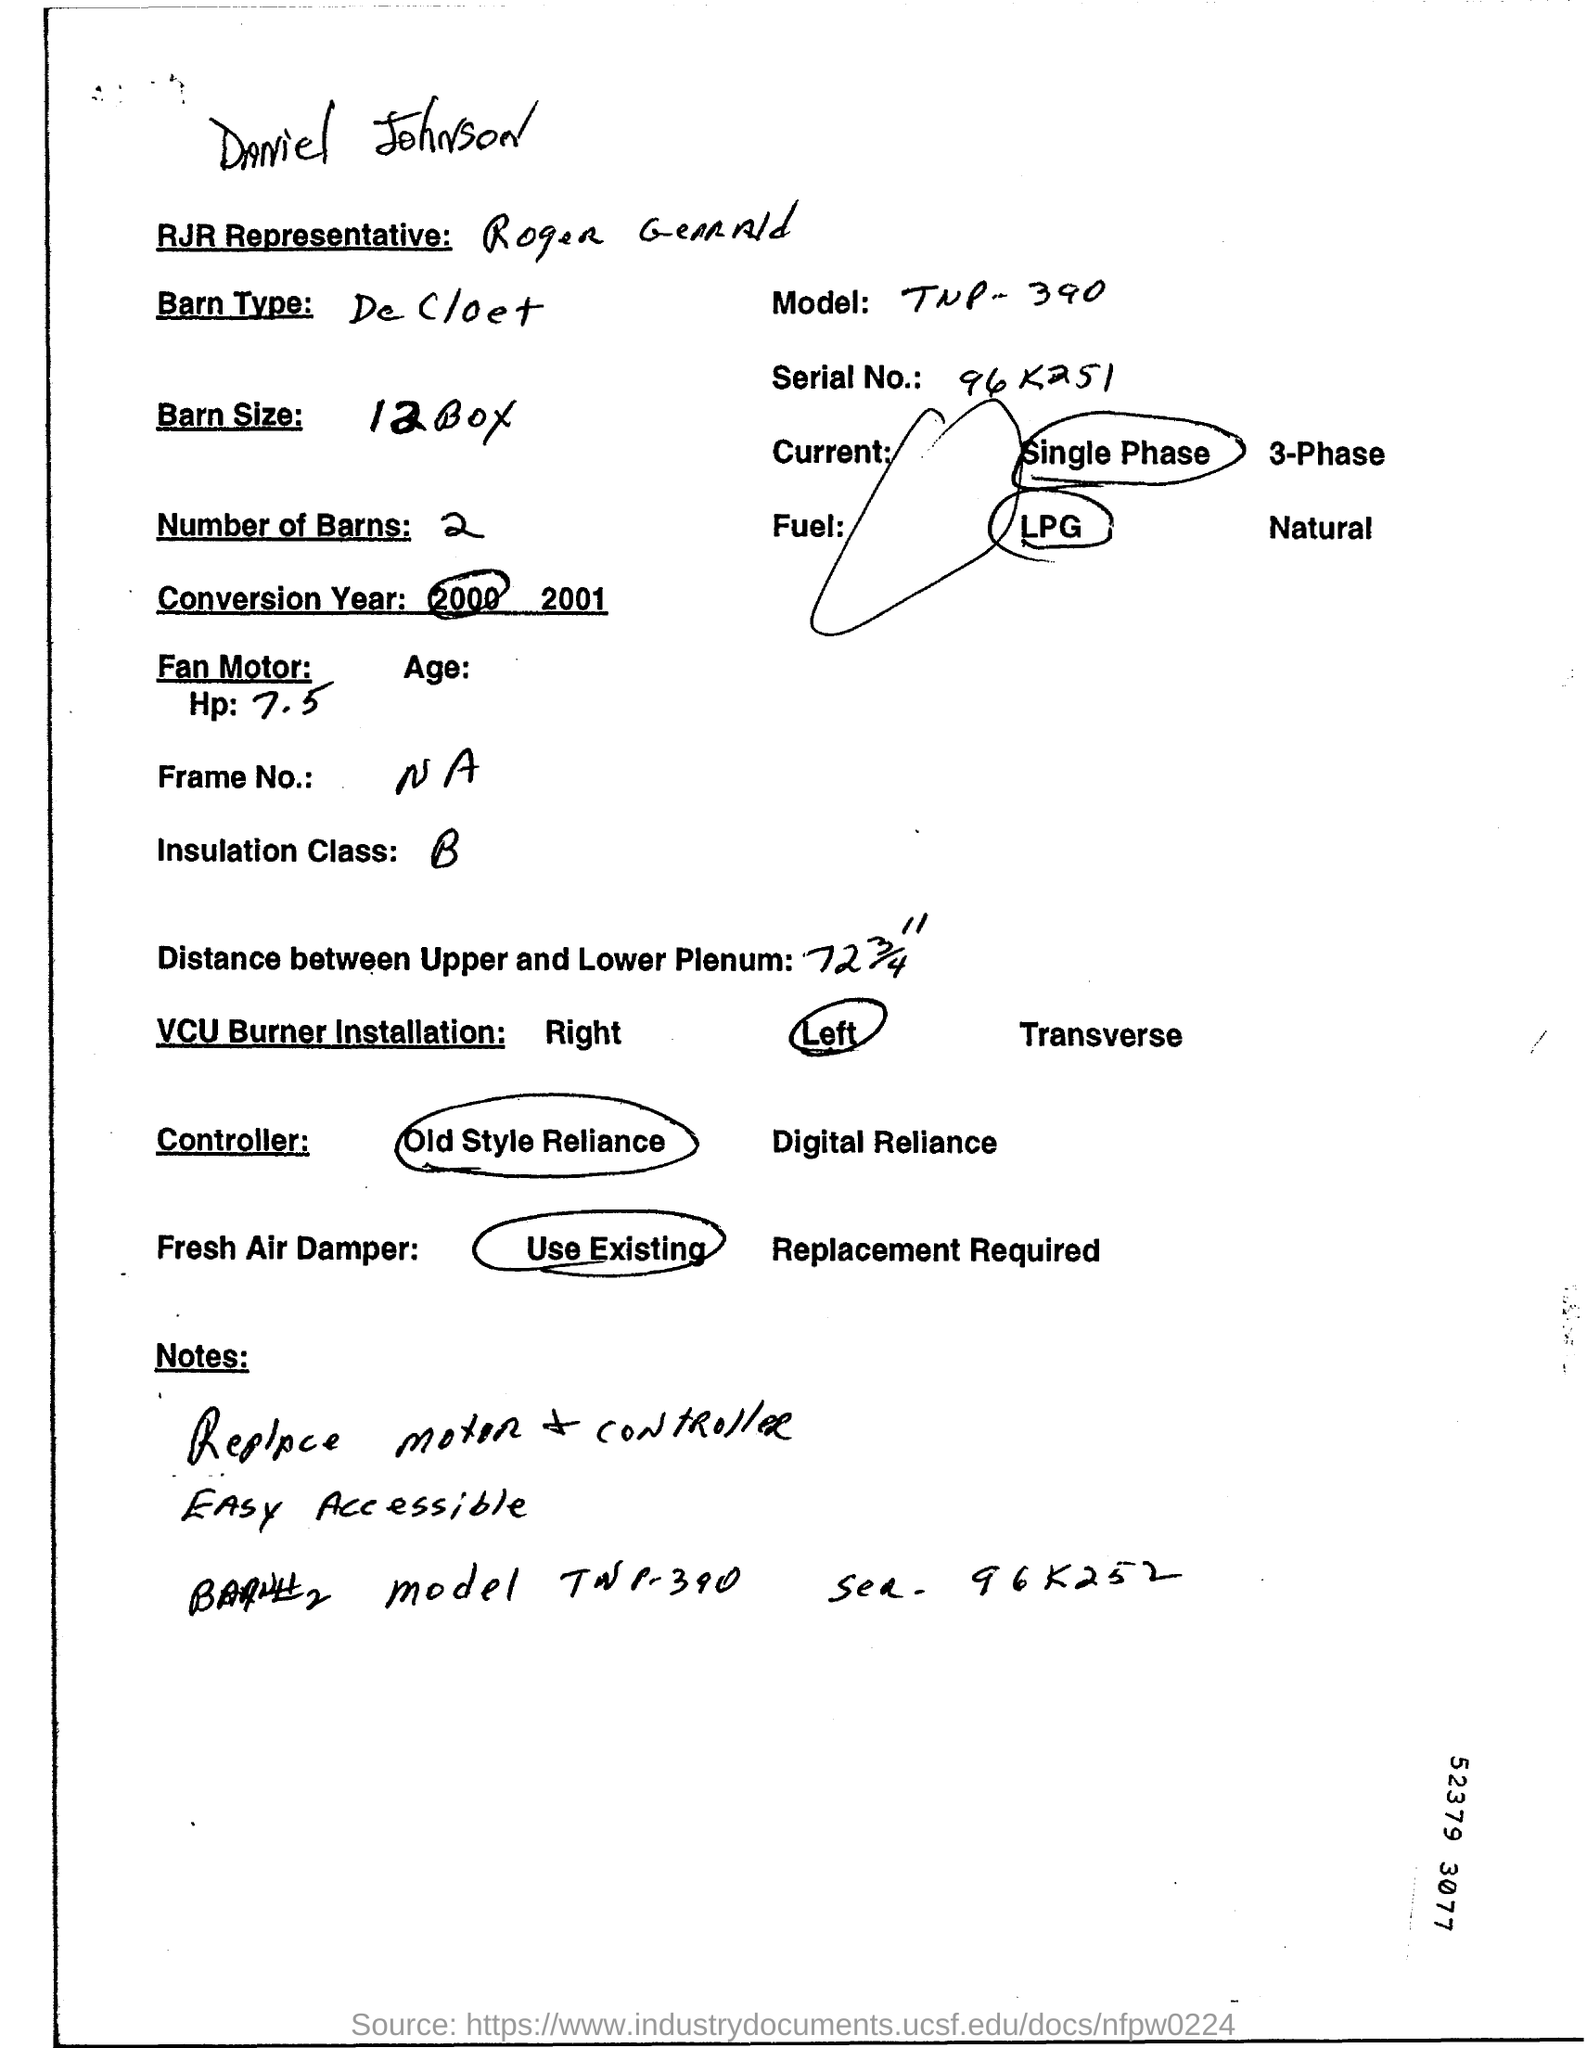Specify some key components in this picture. The serial number mentioned in the document is 96 K251. 